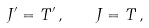<formula> <loc_0><loc_0><loc_500><loc_500>J ^ { \prime } = T ^ { \prime } \, , \quad J = T \, ,</formula> 